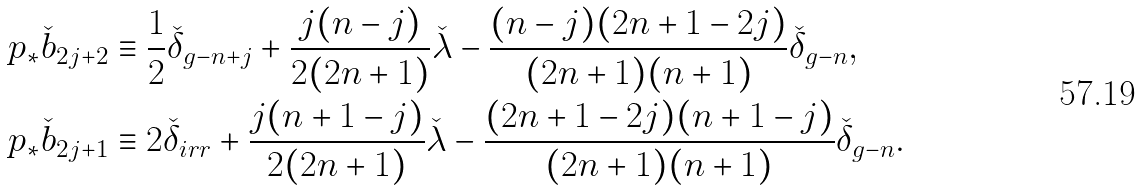Convert formula to latex. <formula><loc_0><loc_0><loc_500><loc_500>p _ { * } \check { b } _ { 2 j + 2 } & \equiv \frac { 1 } { 2 } \check { \delta } _ { g - n + j } + \frac { j ( n - j ) } { 2 ( 2 n + 1 ) } \check { \lambda } - \frac { ( n - j ) ( 2 n + 1 - 2 j ) } { ( 2 n + 1 ) ( n + 1 ) } \check { \delta } _ { g - n } , \\ p _ { * } \check { b } _ { 2 j + 1 } & \equiv 2 \check { \delta } _ { i r r } + \frac { j ( n + 1 - j ) } { 2 ( 2 n + 1 ) } \check { \lambda } - \frac { ( 2 n + 1 - 2 j ) ( n + 1 - j ) } { ( 2 n + 1 ) ( n + 1 ) } \check { \delta } _ { g - n } . \quad</formula> 